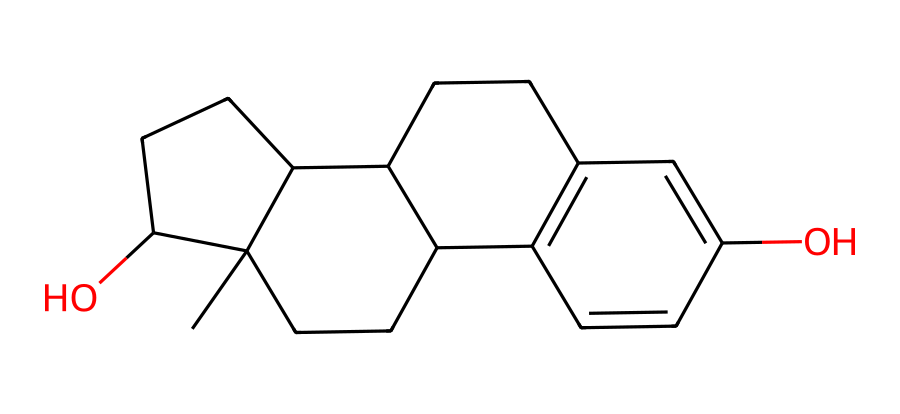What is the primary function of this hormone in the body? Estrogen primarily regulates reproductive functions and secondary sexual characteristics.
Answer: reproductive functions How many hydroxyl (–OH) groups are present in this molecule? By analyzing the structure, we can identify two hydroxyl groups attached to the carbon backbone of the compound.
Answer: 2 What is the molecular formula of this compound? The molecular formula can be deduced from counting the total number of each atom: C18H24O2.
Answer: C18H24O2 Does this compound have any double bonds? Yes, this chemical structure contains multiple double bonds as indicated by the presence of double lines between certain carbon atoms in the ring structures.
Answer: yes What type of biochemical is this compound classified as? Given its role and structure, it is classified as a steroid hormone, as it derives from cholesterol and shares a steroid structure.
Answer: steroid hormone What is the total number of carbon atoms in this compound? By counting the number of carbon atoms represented in the SMILES string, we find there are 18 carbon atoms in total.
Answer: 18 